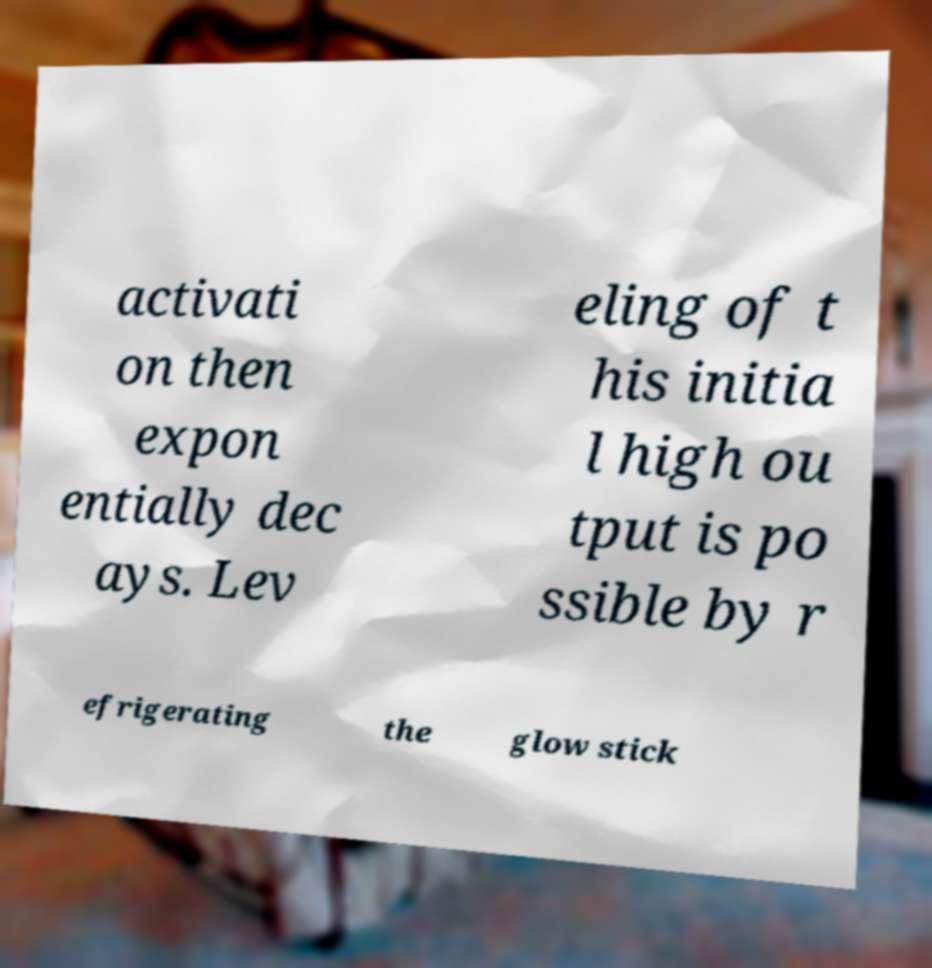For documentation purposes, I need the text within this image transcribed. Could you provide that? activati on then expon entially dec ays. Lev eling of t his initia l high ou tput is po ssible by r efrigerating the glow stick 